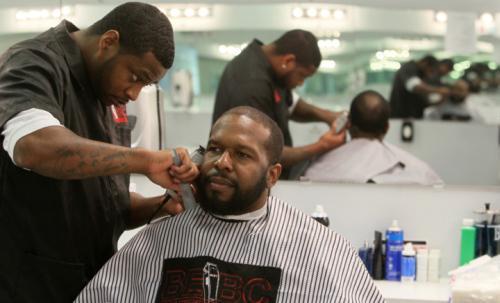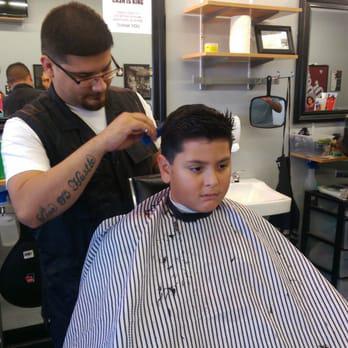The first image is the image on the left, the second image is the image on the right. Analyze the images presented: Is the assertion "An image shows a row of red and black barber chairs, without customers in the chairs in the foreground." valid? Answer yes or no. No. The first image is the image on the left, the second image is the image on the right. Given the left and right images, does the statement "There are black seats in the left side of the shop in the image on the left." hold true? Answer yes or no. No. 